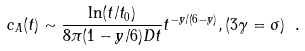Convert formula to latex. <formula><loc_0><loc_0><loc_500><loc_500>c _ { A } ( t ) \sim \frac { \ln ( t / t _ { 0 } ) } { 8 \pi ( 1 - y / 6 ) D t } t ^ { - y / ( 6 - y ) } , ( 3 \gamma = \sigma ) \ .</formula> 